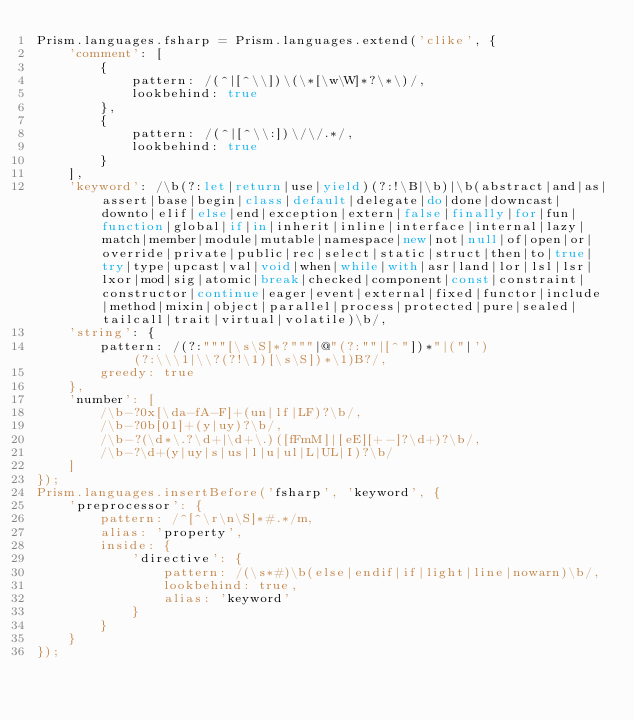Convert code to text. <code><loc_0><loc_0><loc_500><loc_500><_JavaScript_>Prism.languages.fsharp = Prism.languages.extend('clike', {
	'comment': [
		{
			pattern: /(^|[^\\])\(\*[\w\W]*?\*\)/,
			lookbehind: true
		},
		{
			pattern: /(^|[^\\:])\/\/.*/,
			lookbehind: true
		}
	],
	'keyword': /\b(?:let|return|use|yield)(?:!\B|\b)|\b(abstract|and|as|assert|base|begin|class|default|delegate|do|done|downcast|downto|elif|else|end|exception|extern|false|finally|for|fun|function|global|if|in|inherit|inline|interface|internal|lazy|match|member|module|mutable|namespace|new|not|null|of|open|or|override|private|public|rec|select|static|struct|then|to|true|try|type|upcast|val|void|when|while|with|asr|land|lor|lsl|lsr|lxor|mod|sig|atomic|break|checked|component|const|constraint|constructor|continue|eager|event|external|fixed|functor|include|method|mixin|object|parallel|process|protected|pure|sealed|tailcall|trait|virtual|volatile)\b/,
	'string': {
		pattern: /(?:"""[\s\S]*?"""|@"(?:""|[^"])*"|("|')(?:\\\1|\\?(?!\1)[\s\S])*\1)B?/,
		greedy: true
	},
	'number': [
		/\b-?0x[\da-fA-F]+(un|lf|LF)?\b/,
		/\b-?0b[01]+(y|uy)?\b/,
		/\b-?(\d*\.?\d+|\d+\.)([fFmM]|[eE][+-]?\d+)?\b/,
		/\b-?\d+(y|uy|s|us|l|u|ul|L|UL|I)?\b/
	]
});
Prism.languages.insertBefore('fsharp', 'keyword', {
	'preprocessor': {
		pattern: /^[^\r\n\S]*#.*/m,
		alias: 'property',
		inside: {
			'directive': {
				pattern: /(\s*#)\b(else|endif|if|light|line|nowarn)\b/,
				lookbehind: true,
				alias: 'keyword'
			}
		}
	}
});
</code> 